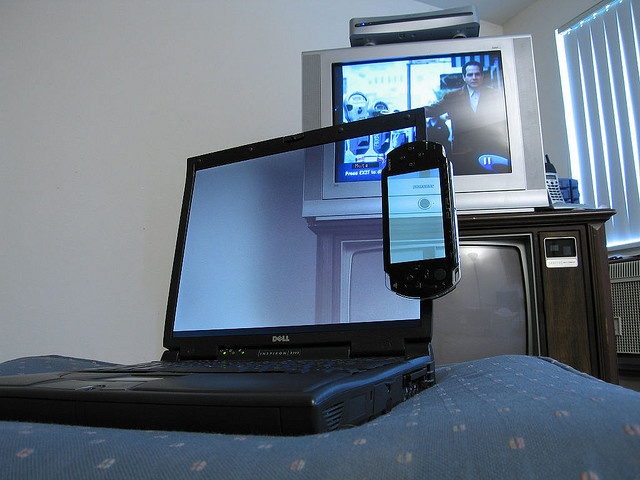Describe the objects in this image and their specific colors. I can see laptop in gray, black, and darkgray tones, bed in gray, blue, and black tones, tv in gray, lightgray, darkgray, and lightblue tones, cell phone in gray, black, and lightblue tones, and tv in gray, black, darkgray, and lightgray tones in this image. 